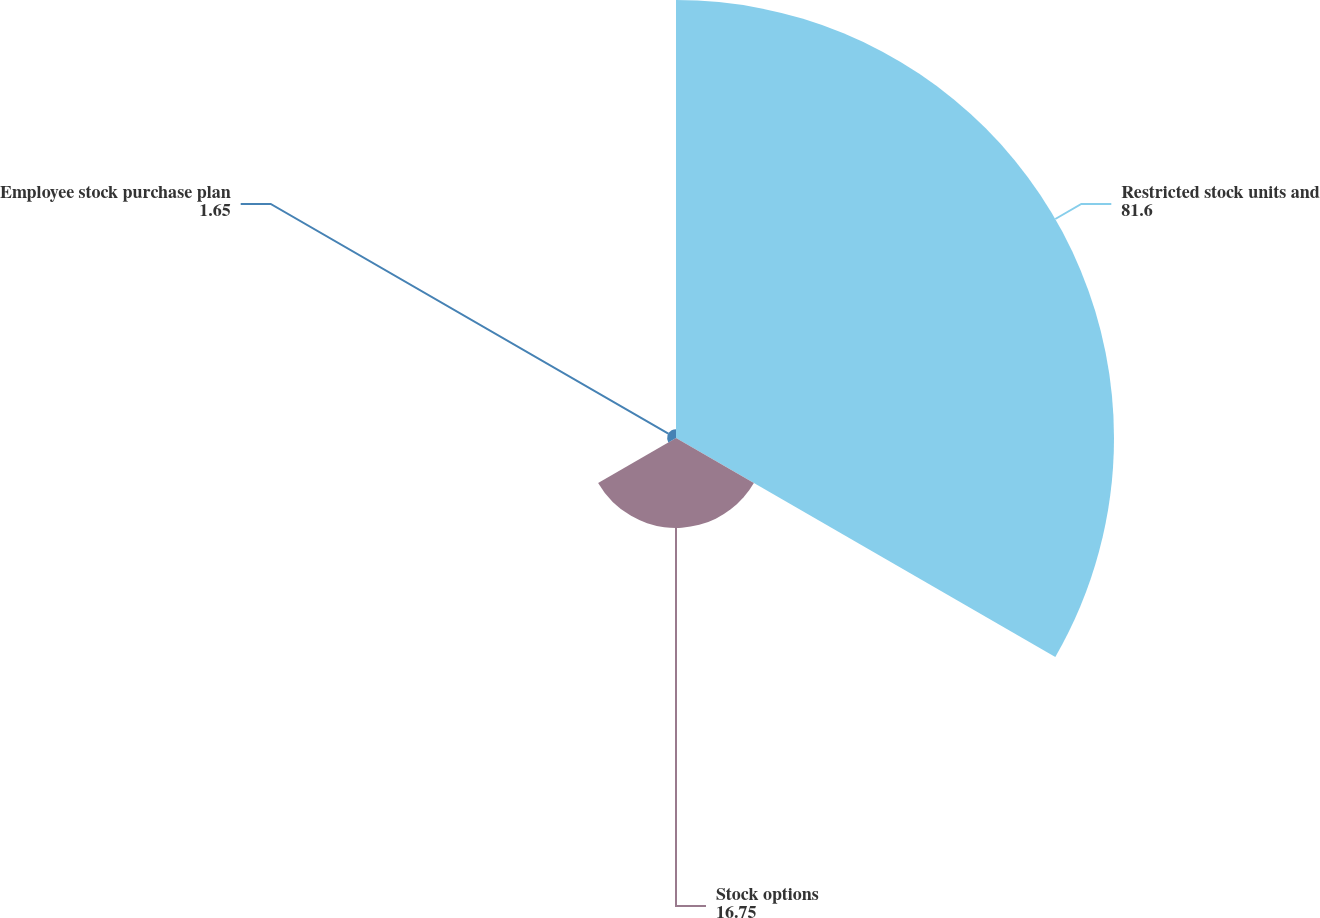<chart> <loc_0><loc_0><loc_500><loc_500><pie_chart><fcel>Restricted stock units and<fcel>Stock options<fcel>Employee stock purchase plan<nl><fcel>81.6%<fcel>16.75%<fcel>1.65%<nl></chart> 